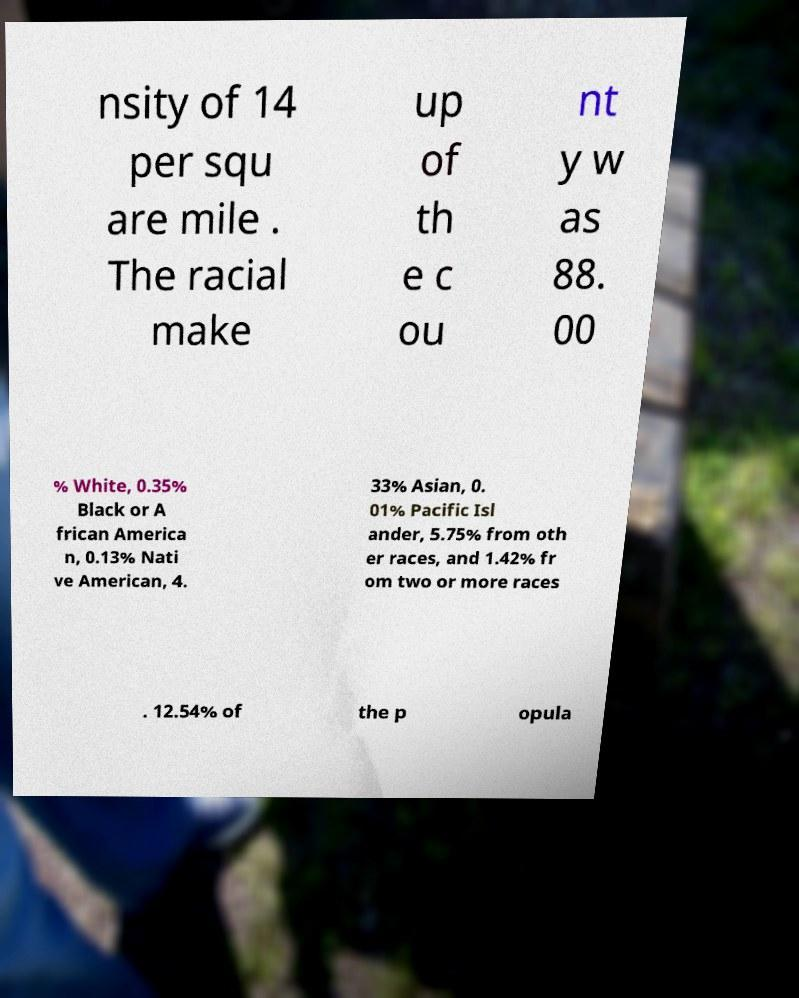Could you assist in decoding the text presented in this image and type it out clearly? nsity of 14 per squ are mile . The racial make up of th e c ou nt y w as 88. 00 % White, 0.35% Black or A frican America n, 0.13% Nati ve American, 4. 33% Asian, 0. 01% Pacific Isl ander, 5.75% from oth er races, and 1.42% fr om two or more races . 12.54% of the p opula 